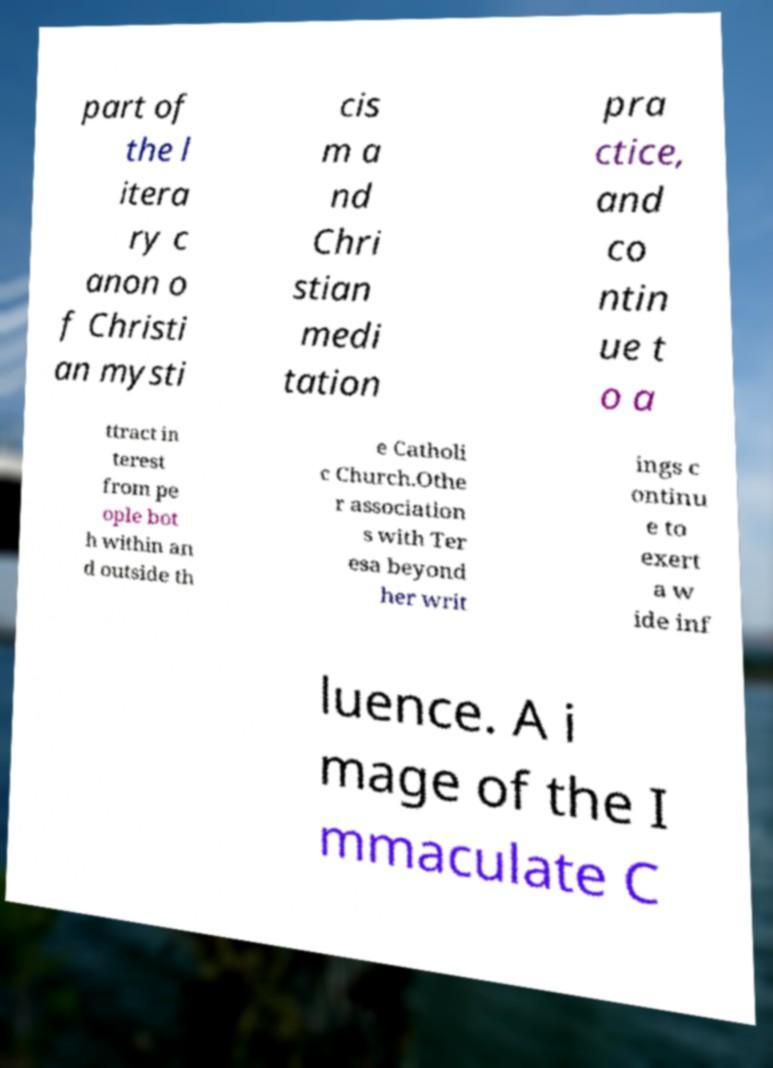Please read and relay the text visible in this image. What does it say? part of the l itera ry c anon o f Christi an mysti cis m a nd Chri stian medi tation pra ctice, and co ntin ue t o a ttract in terest from pe ople bot h within an d outside th e Catholi c Church.Othe r association s with Ter esa beyond her writ ings c ontinu e to exert a w ide inf luence. A i mage of the I mmaculate C 